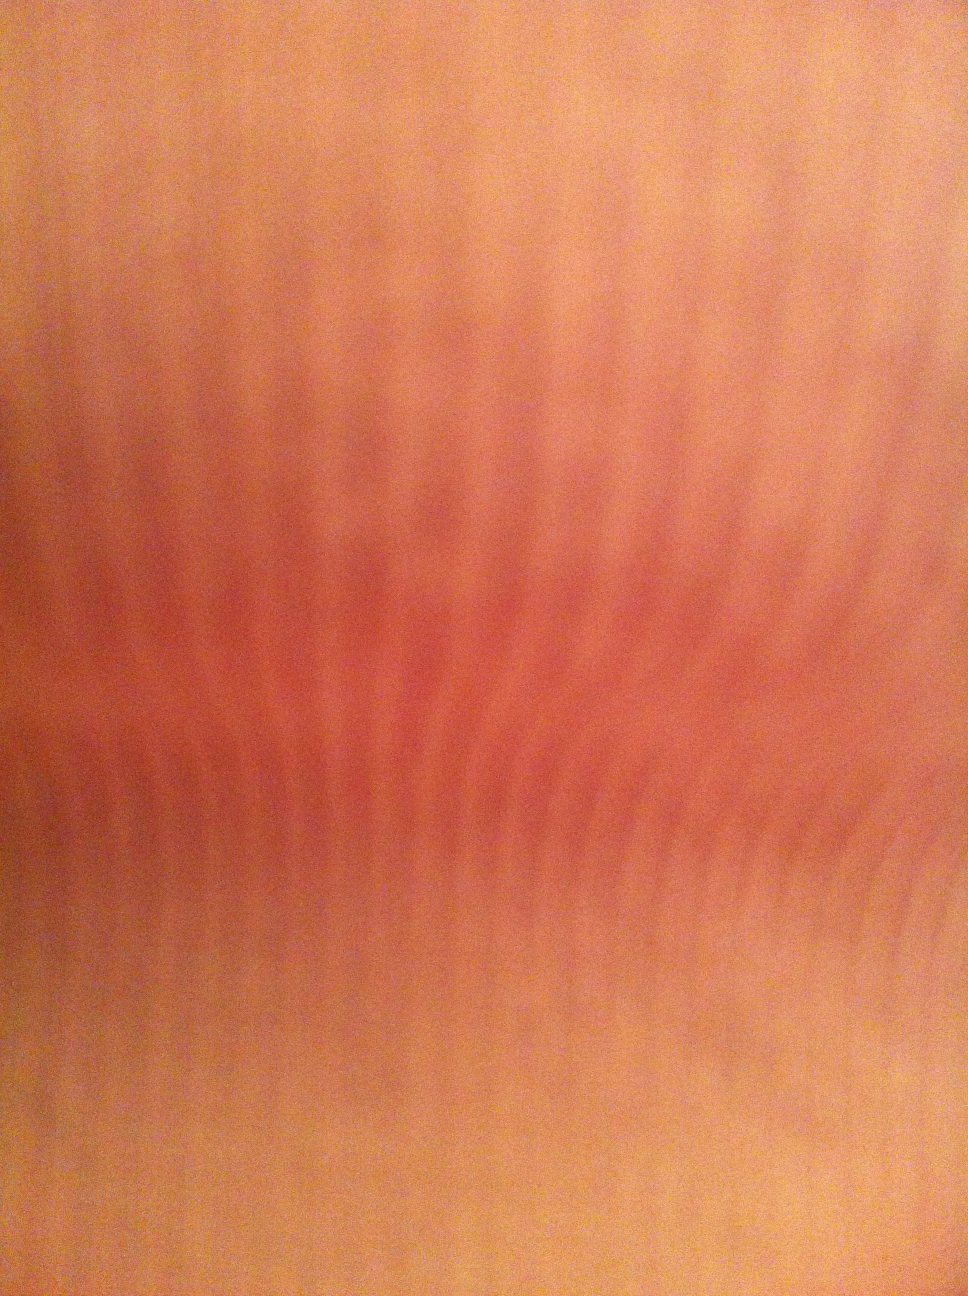What color is this? The predominant color in the image is a shade of peach or light orange-toned skin color, possibly indicating a close-up view of human skin. 